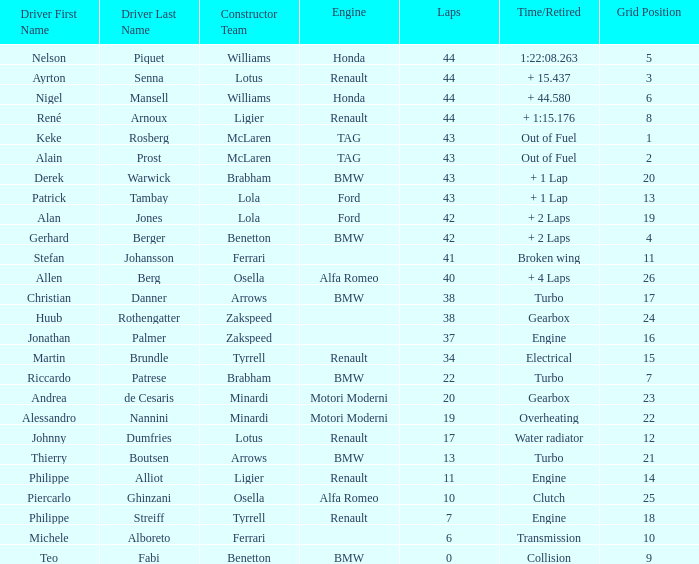I want the driver that has Laps of 10 Piercarlo Ghinzani. 